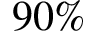Convert formula to latex. <formula><loc_0><loc_0><loc_500><loc_500>9 0 \%</formula> 